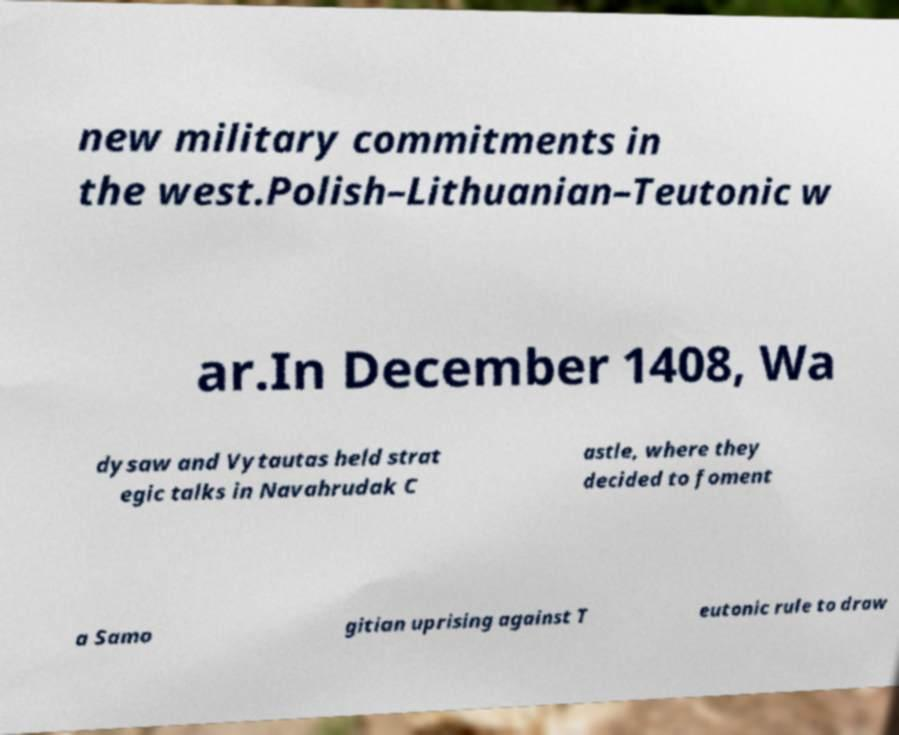For documentation purposes, I need the text within this image transcribed. Could you provide that? new military commitments in the west.Polish–Lithuanian–Teutonic w ar.In December 1408, Wa dysaw and Vytautas held strat egic talks in Navahrudak C astle, where they decided to foment a Samo gitian uprising against T eutonic rule to draw 